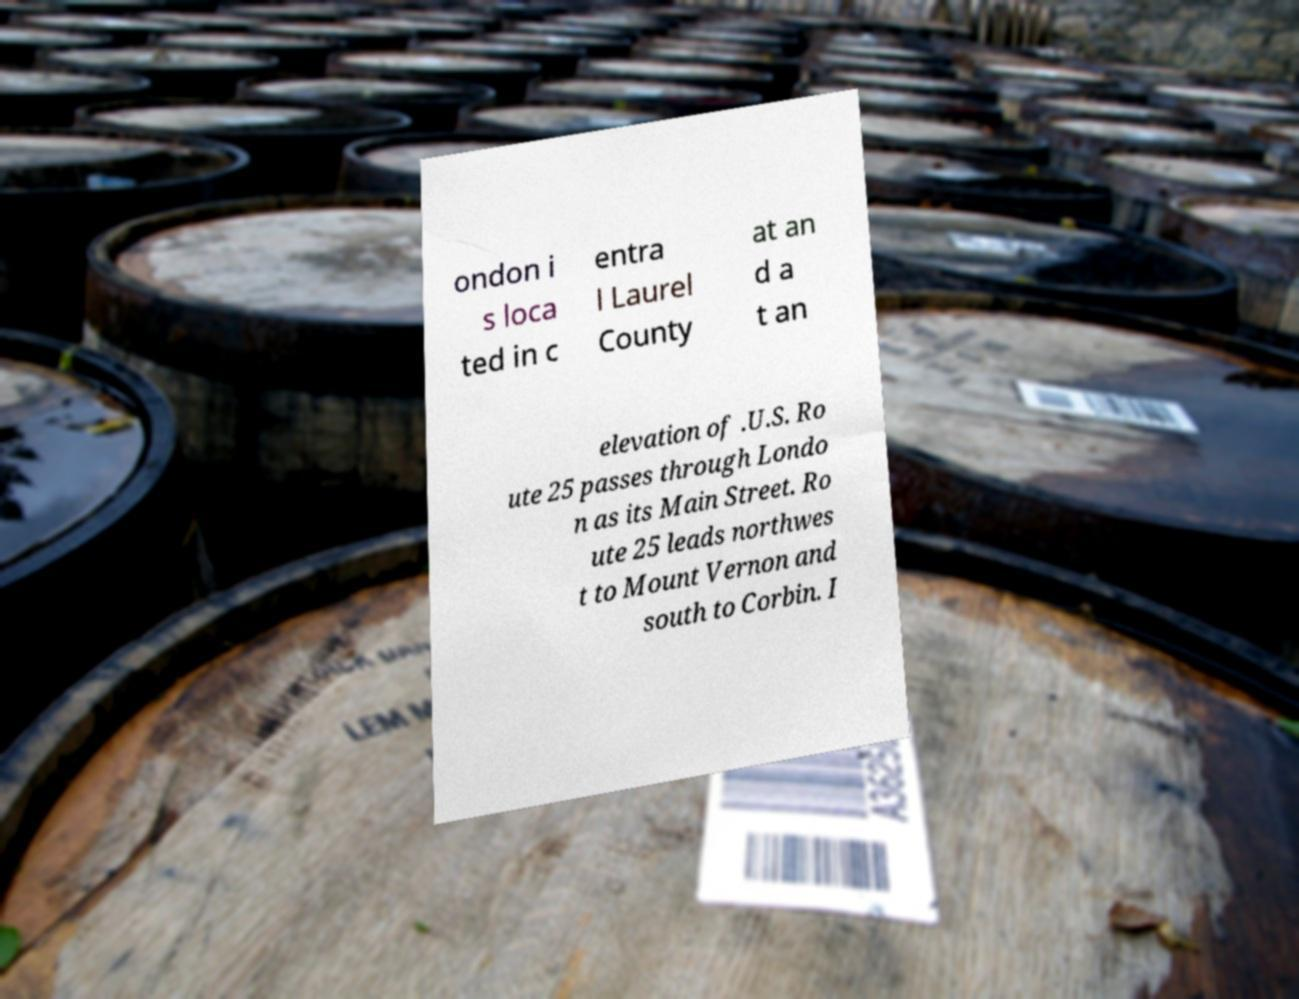Could you assist in decoding the text presented in this image and type it out clearly? ondon i s loca ted in c entra l Laurel County at an d a t an elevation of .U.S. Ro ute 25 passes through Londo n as its Main Street. Ro ute 25 leads northwes t to Mount Vernon and south to Corbin. I 